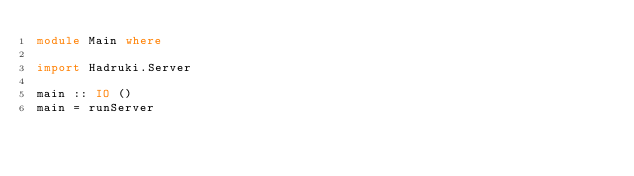Convert code to text. <code><loc_0><loc_0><loc_500><loc_500><_Haskell_>module Main where

import Hadruki.Server

main :: IO ()
main = runServer
</code> 